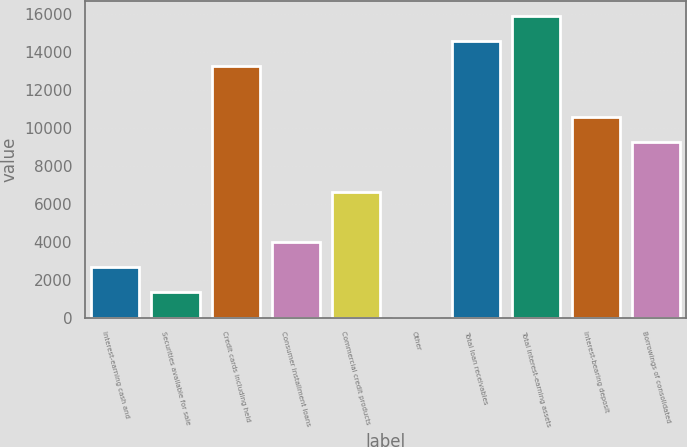<chart> <loc_0><loc_0><loc_500><loc_500><bar_chart><fcel>Interest-earning cash and<fcel>Securities available for sale<fcel>Credit cards including held<fcel>Consumer installment loans<fcel>Commercial credit products<fcel>Other<fcel>Total loan receivables<fcel>Total interest-earning assets<fcel>Interest-bearing deposit<fcel>Borrowings of consolidated<nl><fcel>2646.4<fcel>1323.7<fcel>13228<fcel>3969.1<fcel>6614.5<fcel>1<fcel>14550.7<fcel>15873.4<fcel>10582.6<fcel>9259.9<nl></chart> 